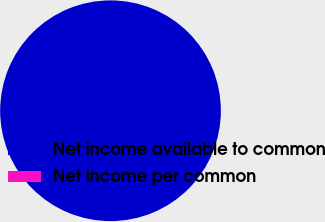Convert chart to OTSL. <chart><loc_0><loc_0><loc_500><loc_500><pie_chart><fcel>Net income available to common<fcel>Net income per common<nl><fcel>100.0%<fcel>0.0%<nl></chart> 